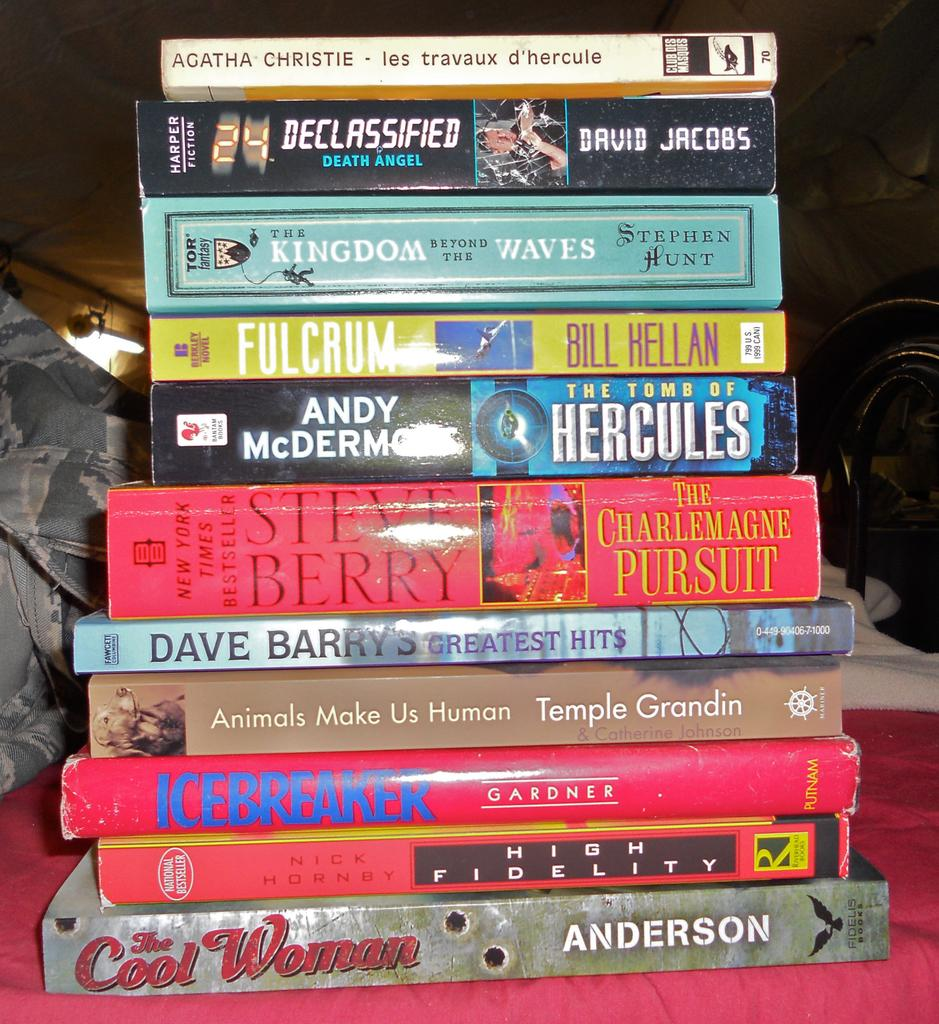<image>
Render a clear and concise summary of the photo. A book by Steve Berry sits in the middle of a stack of books 